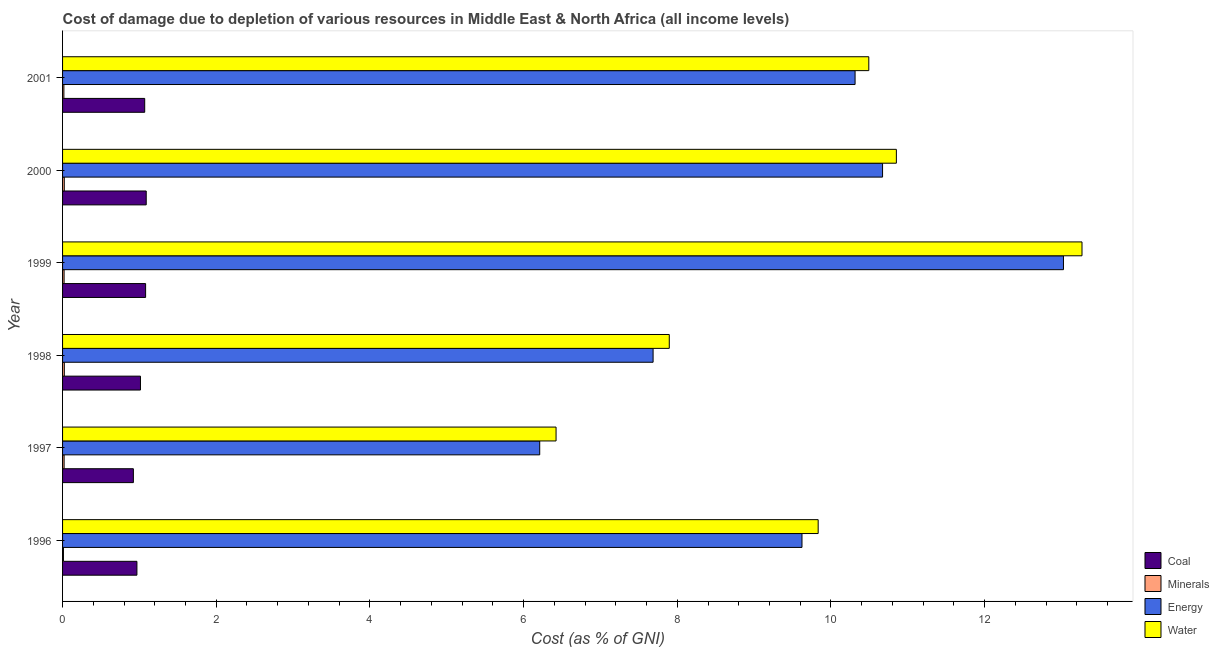Are the number of bars on each tick of the Y-axis equal?
Give a very brief answer. Yes. How many bars are there on the 5th tick from the top?
Provide a succinct answer. 4. How many bars are there on the 5th tick from the bottom?
Give a very brief answer. 4. What is the label of the 4th group of bars from the top?
Offer a terse response. 1998. In how many cases, is the number of bars for a given year not equal to the number of legend labels?
Give a very brief answer. 0. What is the cost of damage due to depletion of coal in 2000?
Provide a succinct answer. 1.09. Across all years, what is the maximum cost of damage due to depletion of coal?
Offer a very short reply. 1.09. Across all years, what is the minimum cost of damage due to depletion of minerals?
Keep it short and to the point. 0.01. In which year was the cost of damage due to depletion of water minimum?
Offer a very short reply. 1997. What is the total cost of damage due to depletion of coal in the graph?
Your answer should be very brief. 6.14. What is the difference between the cost of damage due to depletion of water in 1997 and that in 1998?
Your answer should be very brief. -1.47. What is the difference between the cost of damage due to depletion of coal in 1996 and the cost of damage due to depletion of water in 1998?
Keep it short and to the point. -6.93. What is the average cost of damage due to depletion of minerals per year?
Provide a short and direct response. 0.02. In the year 1999, what is the difference between the cost of damage due to depletion of coal and cost of damage due to depletion of energy?
Provide a short and direct response. -11.95. What is the ratio of the cost of damage due to depletion of minerals in 1996 to that in 1997?
Offer a terse response. 0.57. Is the difference between the cost of damage due to depletion of energy in 2000 and 2001 greater than the difference between the cost of damage due to depletion of minerals in 2000 and 2001?
Offer a very short reply. Yes. What is the difference between the highest and the second highest cost of damage due to depletion of water?
Your answer should be very brief. 2.42. What is the difference between the highest and the lowest cost of damage due to depletion of water?
Provide a succinct answer. 6.84. Is the sum of the cost of damage due to depletion of coal in 2000 and 2001 greater than the maximum cost of damage due to depletion of water across all years?
Keep it short and to the point. No. Is it the case that in every year, the sum of the cost of damage due to depletion of water and cost of damage due to depletion of energy is greater than the sum of cost of damage due to depletion of minerals and cost of damage due to depletion of coal?
Your answer should be compact. Yes. What does the 1st bar from the top in 1998 represents?
Ensure brevity in your answer.  Water. What does the 2nd bar from the bottom in 1998 represents?
Make the answer very short. Minerals. Is it the case that in every year, the sum of the cost of damage due to depletion of coal and cost of damage due to depletion of minerals is greater than the cost of damage due to depletion of energy?
Offer a terse response. No. How many years are there in the graph?
Your answer should be compact. 6. What is the difference between two consecutive major ticks on the X-axis?
Offer a very short reply. 2. Does the graph contain grids?
Your answer should be very brief. No. Where does the legend appear in the graph?
Provide a succinct answer. Bottom right. How many legend labels are there?
Offer a terse response. 4. How are the legend labels stacked?
Give a very brief answer. Vertical. What is the title of the graph?
Your answer should be very brief. Cost of damage due to depletion of various resources in Middle East & North Africa (all income levels) . Does "SF6 gas" appear as one of the legend labels in the graph?
Offer a very short reply. No. What is the label or title of the X-axis?
Keep it short and to the point. Cost (as % of GNI). What is the label or title of the Y-axis?
Provide a short and direct response. Year. What is the Cost (as % of GNI) in Coal in 1996?
Your response must be concise. 0.97. What is the Cost (as % of GNI) of Minerals in 1996?
Keep it short and to the point. 0.01. What is the Cost (as % of GNI) in Energy in 1996?
Provide a short and direct response. 9.62. What is the Cost (as % of GNI) in Water in 1996?
Provide a short and direct response. 9.83. What is the Cost (as % of GNI) of Coal in 1997?
Your answer should be compact. 0.92. What is the Cost (as % of GNI) of Minerals in 1997?
Offer a terse response. 0.02. What is the Cost (as % of GNI) in Energy in 1997?
Make the answer very short. 6.21. What is the Cost (as % of GNI) in Water in 1997?
Offer a terse response. 6.42. What is the Cost (as % of GNI) of Coal in 1998?
Give a very brief answer. 1.01. What is the Cost (as % of GNI) in Minerals in 1998?
Your answer should be compact. 0.02. What is the Cost (as % of GNI) of Energy in 1998?
Offer a terse response. 7.69. What is the Cost (as % of GNI) in Water in 1998?
Make the answer very short. 7.9. What is the Cost (as % of GNI) in Coal in 1999?
Your response must be concise. 1.08. What is the Cost (as % of GNI) of Minerals in 1999?
Give a very brief answer. 0.02. What is the Cost (as % of GNI) of Energy in 1999?
Offer a terse response. 13.03. What is the Cost (as % of GNI) in Water in 1999?
Provide a succinct answer. 13.27. What is the Cost (as % of GNI) of Coal in 2000?
Your answer should be very brief. 1.09. What is the Cost (as % of GNI) of Minerals in 2000?
Your answer should be compact. 0.02. What is the Cost (as % of GNI) of Energy in 2000?
Provide a succinct answer. 10.67. What is the Cost (as % of GNI) in Water in 2000?
Provide a short and direct response. 10.85. What is the Cost (as % of GNI) in Coal in 2001?
Your response must be concise. 1.07. What is the Cost (as % of GNI) in Minerals in 2001?
Provide a succinct answer. 0.02. What is the Cost (as % of GNI) of Energy in 2001?
Your response must be concise. 10.31. What is the Cost (as % of GNI) in Water in 2001?
Your answer should be compact. 10.49. Across all years, what is the maximum Cost (as % of GNI) of Coal?
Your answer should be compact. 1.09. Across all years, what is the maximum Cost (as % of GNI) in Minerals?
Ensure brevity in your answer.  0.02. Across all years, what is the maximum Cost (as % of GNI) of Energy?
Your response must be concise. 13.03. Across all years, what is the maximum Cost (as % of GNI) of Water?
Offer a terse response. 13.27. Across all years, what is the minimum Cost (as % of GNI) of Coal?
Make the answer very short. 0.92. Across all years, what is the minimum Cost (as % of GNI) in Minerals?
Offer a very short reply. 0.01. Across all years, what is the minimum Cost (as % of GNI) in Energy?
Your response must be concise. 6.21. Across all years, what is the minimum Cost (as % of GNI) of Water?
Offer a terse response. 6.42. What is the total Cost (as % of GNI) in Coal in the graph?
Provide a succinct answer. 6.14. What is the total Cost (as % of GNI) in Minerals in the graph?
Provide a short and direct response. 0.11. What is the total Cost (as % of GNI) in Energy in the graph?
Offer a very short reply. 57.53. What is the total Cost (as % of GNI) of Water in the graph?
Keep it short and to the point. 58.76. What is the difference between the Cost (as % of GNI) of Coal in 1996 and that in 1997?
Keep it short and to the point. 0.05. What is the difference between the Cost (as % of GNI) of Minerals in 1996 and that in 1997?
Your response must be concise. -0.01. What is the difference between the Cost (as % of GNI) in Energy in 1996 and that in 1997?
Keep it short and to the point. 3.41. What is the difference between the Cost (as % of GNI) in Water in 1996 and that in 1997?
Your answer should be very brief. 3.41. What is the difference between the Cost (as % of GNI) of Coal in 1996 and that in 1998?
Your response must be concise. -0.05. What is the difference between the Cost (as % of GNI) of Minerals in 1996 and that in 1998?
Offer a very short reply. -0.01. What is the difference between the Cost (as % of GNI) of Energy in 1996 and that in 1998?
Offer a very short reply. 1.94. What is the difference between the Cost (as % of GNI) in Water in 1996 and that in 1998?
Give a very brief answer. 1.94. What is the difference between the Cost (as % of GNI) of Coal in 1996 and that in 1999?
Provide a succinct answer. -0.11. What is the difference between the Cost (as % of GNI) of Minerals in 1996 and that in 1999?
Ensure brevity in your answer.  -0.01. What is the difference between the Cost (as % of GNI) of Energy in 1996 and that in 1999?
Make the answer very short. -3.4. What is the difference between the Cost (as % of GNI) in Water in 1996 and that in 1999?
Your response must be concise. -3.43. What is the difference between the Cost (as % of GNI) of Coal in 1996 and that in 2000?
Ensure brevity in your answer.  -0.12. What is the difference between the Cost (as % of GNI) in Minerals in 1996 and that in 2000?
Your answer should be compact. -0.01. What is the difference between the Cost (as % of GNI) in Energy in 1996 and that in 2000?
Ensure brevity in your answer.  -1.05. What is the difference between the Cost (as % of GNI) of Water in 1996 and that in 2000?
Your response must be concise. -1.02. What is the difference between the Cost (as % of GNI) in Coal in 1996 and that in 2001?
Your answer should be compact. -0.1. What is the difference between the Cost (as % of GNI) of Minerals in 1996 and that in 2001?
Provide a short and direct response. -0.01. What is the difference between the Cost (as % of GNI) in Energy in 1996 and that in 2001?
Give a very brief answer. -0.69. What is the difference between the Cost (as % of GNI) of Water in 1996 and that in 2001?
Ensure brevity in your answer.  -0.66. What is the difference between the Cost (as % of GNI) in Coal in 1997 and that in 1998?
Your answer should be compact. -0.09. What is the difference between the Cost (as % of GNI) in Minerals in 1997 and that in 1998?
Offer a terse response. -0. What is the difference between the Cost (as % of GNI) of Energy in 1997 and that in 1998?
Provide a short and direct response. -1.48. What is the difference between the Cost (as % of GNI) of Water in 1997 and that in 1998?
Your answer should be compact. -1.47. What is the difference between the Cost (as % of GNI) in Coal in 1997 and that in 1999?
Your answer should be compact. -0.16. What is the difference between the Cost (as % of GNI) in Energy in 1997 and that in 1999?
Your response must be concise. -6.82. What is the difference between the Cost (as % of GNI) in Water in 1997 and that in 1999?
Your answer should be compact. -6.84. What is the difference between the Cost (as % of GNI) in Coal in 1997 and that in 2000?
Provide a succinct answer. -0.17. What is the difference between the Cost (as % of GNI) in Minerals in 1997 and that in 2000?
Your answer should be very brief. -0. What is the difference between the Cost (as % of GNI) in Energy in 1997 and that in 2000?
Your response must be concise. -4.46. What is the difference between the Cost (as % of GNI) of Water in 1997 and that in 2000?
Your response must be concise. -4.43. What is the difference between the Cost (as % of GNI) of Coal in 1997 and that in 2001?
Your response must be concise. -0.15. What is the difference between the Cost (as % of GNI) in Minerals in 1997 and that in 2001?
Provide a short and direct response. 0. What is the difference between the Cost (as % of GNI) of Energy in 1997 and that in 2001?
Make the answer very short. -4.1. What is the difference between the Cost (as % of GNI) of Water in 1997 and that in 2001?
Your answer should be compact. -4.07. What is the difference between the Cost (as % of GNI) in Coal in 1998 and that in 1999?
Your answer should be very brief. -0.07. What is the difference between the Cost (as % of GNI) in Minerals in 1998 and that in 1999?
Make the answer very short. 0. What is the difference between the Cost (as % of GNI) of Energy in 1998 and that in 1999?
Keep it short and to the point. -5.34. What is the difference between the Cost (as % of GNI) of Water in 1998 and that in 1999?
Ensure brevity in your answer.  -5.37. What is the difference between the Cost (as % of GNI) in Coal in 1998 and that in 2000?
Provide a succinct answer. -0.07. What is the difference between the Cost (as % of GNI) of Minerals in 1998 and that in 2000?
Give a very brief answer. 0. What is the difference between the Cost (as % of GNI) of Energy in 1998 and that in 2000?
Ensure brevity in your answer.  -2.99. What is the difference between the Cost (as % of GNI) of Water in 1998 and that in 2000?
Keep it short and to the point. -2.96. What is the difference between the Cost (as % of GNI) of Coal in 1998 and that in 2001?
Your answer should be very brief. -0.06. What is the difference between the Cost (as % of GNI) of Minerals in 1998 and that in 2001?
Give a very brief answer. 0.01. What is the difference between the Cost (as % of GNI) in Energy in 1998 and that in 2001?
Make the answer very short. -2.63. What is the difference between the Cost (as % of GNI) in Water in 1998 and that in 2001?
Make the answer very short. -2.6. What is the difference between the Cost (as % of GNI) of Coal in 1999 and that in 2000?
Make the answer very short. -0.01. What is the difference between the Cost (as % of GNI) in Minerals in 1999 and that in 2000?
Make the answer very short. -0. What is the difference between the Cost (as % of GNI) of Energy in 1999 and that in 2000?
Your answer should be very brief. 2.35. What is the difference between the Cost (as % of GNI) of Water in 1999 and that in 2000?
Ensure brevity in your answer.  2.42. What is the difference between the Cost (as % of GNI) of Coal in 1999 and that in 2001?
Offer a very short reply. 0.01. What is the difference between the Cost (as % of GNI) in Minerals in 1999 and that in 2001?
Your response must be concise. 0. What is the difference between the Cost (as % of GNI) in Energy in 1999 and that in 2001?
Your answer should be very brief. 2.71. What is the difference between the Cost (as % of GNI) in Water in 1999 and that in 2001?
Your answer should be very brief. 2.77. What is the difference between the Cost (as % of GNI) in Coal in 2000 and that in 2001?
Make the answer very short. 0.02. What is the difference between the Cost (as % of GNI) in Minerals in 2000 and that in 2001?
Your answer should be compact. 0.01. What is the difference between the Cost (as % of GNI) in Energy in 2000 and that in 2001?
Make the answer very short. 0.36. What is the difference between the Cost (as % of GNI) of Water in 2000 and that in 2001?
Offer a terse response. 0.36. What is the difference between the Cost (as % of GNI) in Coal in 1996 and the Cost (as % of GNI) in Minerals in 1997?
Keep it short and to the point. 0.95. What is the difference between the Cost (as % of GNI) in Coal in 1996 and the Cost (as % of GNI) in Energy in 1997?
Ensure brevity in your answer.  -5.24. What is the difference between the Cost (as % of GNI) in Coal in 1996 and the Cost (as % of GNI) in Water in 1997?
Offer a very short reply. -5.45. What is the difference between the Cost (as % of GNI) in Minerals in 1996 and the Cost (as % of GNI) in Energy in 1997?
Your answer should be very brief. -6.2. What is the difference between the Cost (as % of GNI) of Minerals in 1996 and the Cost (as % of GNI) of Water in 1997?
Keep it short and to the point. -6.41. What is the difference between the Cost (as % of GNI) of Energy in 1996 and the Cost (as % of GNI) of Water in 1997?
Your answer should be compact. 3.2. What is the difference between the Cost (as % of GNI) in Coal in 1996 and the Cost (as % of GNI) in Minerals in 1998?
Make the answer very short. 0.94. What is the difference between the Cost (as % of GNI) in Coal in 1996 and the Cost (as % of GNI) in Energy in 1998?
Make the answer very short. -6.72. What is the difference between the Cost (as % of GNI) of Coal in 1996 and the Cost (as % of GNI) of Water in 1998?
Your response must be concise. -6.93. What is the difference between the Cost (as % of GNI) in Minerals in 1996 and the Cost (as % of GNI) in Energy in 1998?
Your response must be concise. -7.67. What is the difference between the Cost (as % of GNI) of Minerals in 1996 and the Cost (as % of GNI) of Water in 1998?
Give a very brief answer. -7.88. What is the difference between the Cost (as % of GNI) in Energy in 1996 and the Cost (as % of GNI) in Water in 1998?
Make the answer very short. 1.73. What is the difference between the Cost (as % of GNI) of Coal in 1996 and the Cost (as % of GNI) of Minerals in 1999?
Make the answer very short. 0.95. What is the difference between the Cost (as % of GNI) in Coal in 1996 and the Cost (as % of GNI) in Energy in 1999?
Offer a very short reply. -12.06. What is the difference between the Cost (as % of GNI) in Coal in 1996 and the Cost (as % of GNI) in Water in 1999?
Provide a short and direct response. -12.3. What is the difference between the Cost (as % of GNI) of Minerals in 1996 and the Cost (as % of GNI) of Energy in 1999?
Your answer should be very brief. -13.01. What is the difference between the Cost (as % of GNI) in Minerals in 1996 and the Cost (as % of GNI) in Water in 1999?
Make the answer very short. -13.26. What is the difference between the Cost (as % of GNI) in Energy in 1996 and the Cost (as % of GNI) in Water in 1999?
Your answer should be very brief. -3.64. What is the difference between the Cost (as % of GNI) of Coal in 1996 and the Cost (as % of GNI) of Minerals in 2000?
Your response must be concise. 0.95. What is the difference between the Cost (as % of GNI) in Coal in 1996 and the Cost (as % of GNI) in Energy in 2000?
Give a very brief answer. -9.7. What is the difference between the Cost (as % of GNI) of Coal in 1996 and the Cost (as % of GNI) of Water in 2000?
Your response must be concise. -9.88. What is the difference between the Cost (as % of GNI) of Minerals in 1996 and the Cost (as % of GNI) of Energy in 2000?
Offer a terse response. -10.66. What is the difference between the Cost (as % of GNI) in Minerals in 1996 and the Cost (as % of GNI) in Water in 2000?
Offer a terse response. -10.84. What is the difference between the Cost (as % of GNI) of Energy in 1996 and the Cost (as % of GNI) of Water in 2000?
Your answer should be very brief. -1.23. What is the difference between the Cost (as % of GNI) in Coal in 1996 and the Cost (as % of GNI) in Minerals in 2001?
Provide a succinct answer. 0.95. What is the difference between the Cost (as % of GNI) of Coal in 1996 and the Cost (as % of GNI) of Energy in 2001?
Keep it short and to the point. -9.35. What is the difference between the Cost (as % of GNI) of Coal in 1996 and the Cost (as % of GNI) of Water in 2001?
Provide a succinct answer. -9.52. What is the difference between the Cost (as % of GNI) in Minerals in 1996 and the Cost (as % of GNI) in Energy in 2001?
Offer a terse response. -10.3. What is the difference between the Cost (as % of GNI) in Minerals in 1996 and the Cost (as % of GNI) in Water in 2001?
Offer a very short reply. -10.48. What is the difference between the Cost (as % of GNI) in Energy in 1996 and the Cost (as % of GNI) in Water in 2001?
Give a very brief answer. -0.87. What is the difference between the Cost (as % of GNI) of Coal in 1997 and the Cost (as % of GNI) of Minerals in 1998?
Ensure brevity in your answer.  0.9. What is the difference between the Cost (as % of GNI) in Coal in 1997 and the Cost (as % of GNI) in Energy in 1998?
Your answer should be compact. -6.76. What is the difference between the Cost (as % of GNI) of Coal in 1997 and the Cost (as % of GNI) of Water in 1998?
Provide a succinct answer. -6.97. What is the difference between the Cost (as % of GNI) in Minerals in 1997 and the Cost (as % of GNI) in Energy in 1998?
Your answer should be very brief. -7.67. What is the difference between the Cost (as % of GNI) in Minerals in 1997 and the Cost (as % of GNI) in Water in 1998?
Provide a succinct answer. -7.88. What is the difference between the Cost (as % of GNI) of Energy in 1997 and the Cost (as % of GNI) of Water in 1998?
Keep it short and to the point. -1.69. What is the difference between the Cost (as % of GNI) in Coal in 1997 and the Cost (as % of GNI) in Minerals in 1999?
Give a very brief answer. 0.9. What is the difference between the Cost (as % of GNI) in Coal in 1997 and the Cost (as % of GNI) in Energy in 1999?
Ensure brevity in your answer.  -12.1. What is the difference between the Cost (as % of GNI) in Coal in 1997 and the Cost (as % of GNI) in Water in 1999?
Your answer should be very brief. -12.35. What is the difference between the Cost (as % of GNI) in Minerals in 1997 and the Cost (as % of GNI) in Energy in 1999?
Offer a terse response. -13.01. What is the difference between the Cost (as % of GNI) in Minerals in 1997 and the Cost (as % of GNI) in Water in 1999?
Offer a very short reply. -13.25. What is the difference between the Cost (as % of GNI) in Energy in 1997 and the Cost (as % of GNI) in Water in 1999?
Offer a very short reply. -7.06. What is the difference between the Cost (as % of GNI) in Coal in 1997 and the Cost (as % of GNI) in Minerals in 2000?
Your answer should be very brief. 0.9. What is the difference between the Cost (as % of GNI) of Coal in 1997 and the Cost (as % of GNI) of Energy in 2000?
Give a very brief answer. -9.75. What is the difference between the Cost (as % of GNI) in Coal in 1997 and the Cost (as % of GNI) in Water in 2000?
Your answer should be compact. -9.93. What is the difference between the Cost (as % of GNI) in Minerals in 1997 and the Cost (as % of GNI) in Energy in 2000?
Your answer should be very brief. -10.65. What is the difference between the Cost (as % of GNI) of Minerals in 1997 and the Cost (as % of GNI) of Water in 2000?
Your answer should be very brief. -10.83. What is the difference between the Cost (as % of GNI) in Energy in 1997 and the Cost (as % of GNI) in Water in 2000?
Ensure brevity in your answer.  -4.64. What is the difference between the Cost (as % of GNI) of Coal in 1997 and the Cost (as % of GNI) of Minerals in 2001?
Provide a short and direct response. 0.9. What is the difference between the Cost (as % of GNI) of Coal in 1997 and the Cost (as % of GNI) of Energy in 2001?
Ensure brevity in your answer.  -9.39. What is the difference between the Cost (as % of GNI) of Coal in 1997 and the Cost (as % of GNI) of Water in 2001?
Provide a succinct answer. -9.57. What is the difference between the Cost (as % of GNI) in Minerals in 1997 and the Cost (as % of GNI) in Energy in 2001?
Ensure brevity in your answer.  -10.29. What is the difference between the Cost (as % of GNI) in Minerals in 1997 and the Cost (as % of GNI) in Water in 2001?
Your answer should be compact. -10.47. What is the difference between the Cost (as % of GNI) of Energy in 1997 and the Cost (as % of GNI) of Water in 2001?
Give a very brief answer. -4.28. What is the difference between the Cost (as % of GNI) in Coal in 1998 and the Cost (as % of GNI) in Energy in 1999?
Ensure brevity in your answer.  -12.01. What is the difference between the Cost (as % of GNI) in Coal in 1998 and the Cost (as % of GNI) in Water in 1999?
Keep it short and to the point. -12.25. What is the difference between the Cost (as % of GNI) of Minerals in 1998 and the Cost (as % of GNI) of Energy in 1999?
Ensure brevity in your answer.  -13. What is the difference between the Cost (as % of GNI) in Minerals in 1998 and the Cost (as % of GNI) in Water in 1999?
Your response must be concise. -13.24. What is the difference between the Cost (as % of GNI) of Energy in 1998 and the Cost (as % of GNI) of Water in 1999?
Keep it short and to the point. -5.58. What is the difference between the Cost (as % of GNI) in Coal in 1998 and the Cost (as % of GNI) in Energy in 2000?
Provide a short and direct response. -9.66. What is the difference between the Cost (as % of GNI) in Coal in 1998 and the Cost (as % of GNI) in Water in 2000?
Give a very brief answer. -9.84. What is the difference between the Cost (as % of GNI) in Minerals in 1998 and the Cost (as % of GNI) in Energy in 2000?
Your answer should be very brief. -10.65. What is the difference between the Cost (as % of GNI) of Minerals in 1998 and the Cost (as % of GNI) of Water in 2000?
Keep it short and to the point. -10.83. What is the difference between the Cost (as % of GNI) in Energy in 1998 and the Cost (as % of GNI) in Water in 2000?
Give a very brief answer. -3.17. What is the difference between the Cost (as % of GNI) in Coal in 1998 and the Cost (as % of GNI) in Minerals in 2001?
Offer a terse response. 1. What is the difference between the Cost (as % of GNI) of Coal in 1998 and the Cost (as % of GNI) of Energy in 2001?
Provide a succinct answer. -9.3. What is the difference between the Cost (as % of GNI) of Coal in 1998 and the Cost (as % of GNI) of Water in 2001?
Your answer should be compact. -9.48. What is the difference between the Cost (as % of GNI) in Minerals in 1998 and the Cost (as % of GNI) in Energy in 2001?
Give a very brief answer. -10.29. What is the difference between the Cost (as % of GNI) of Minerals in 1998 and the Cost (as % of GNI) of Water in 2001?
Keep it short and to the point. -10.47. What is the difference between the Cost (as % of GNI) in Energy in 1998 and the Cost (as % of GNI) in Water in 2001?
Keep it short and to the point. -2.81. What is the difference between the Cost (as % of GNI) of Coal in 1999 and the Cost (as % of GNI) of Minerals in 2000?
Offer a very short reply. 1.06. What is the difference between the Cost (as % of GNI) in Coal in 1999 and the Cost (as % of GNI) in Energy in 2000?
Provide a succinct answer. -9.59. What is the difference between the Cost (as % of GNI) in Coal in 1999 and the Cost (as % of GNI) in Water in 2000?
Ensure brevity in your answer.  -9.77. What is the difference between the Cost (as % of GNI) of Minerals in 1999 and the Cost (as % of GNI) of Energy in 2000?
Make the answer very short. -10.65. What is the difference between the Cost (as % of GNI) in Minerals in 1999 and the Cost (as % of GNI) in Water in 2000?
Your answer should be very brief. -10.83. What is the difference between the Cost (as % of GNI) of Energy in 1999 and the Cost (as % of GNI) of Water in 2000?
Offer a terse response. 2.17. What is the difference between the Cost (as % of GNI) of Coal in 1999 and the Cost (as % of GNI) of Minerals in 2001?
Offer a terse response. 1.06. What is the difference between the Cost (as % of GNI) in Coal in 1999 and the Cost (as % of GNI) in Energy in 2001?
Keep it short and to the point. -9.23. What is the difference between the Cost (as % of GNI) in Coal in 1999 and the Cost (as % of GNI) in Water in 2001?
Offer a terse response. -9.41. What is the difference between the Cost (as % of GNI) of Minerals in 1999 and the Cost (as % of GNI) of Energy in 2001?
Offer a terse response. -10.29. What is the difference between the Cost (as % of GNI) of Minerals in 1999 and the Cost (as % of GNI) of Water in 2001?
Give a very brief answer. -10.47. What is the difference between the Cost (as % of GNI) of Energy in 1999 and the Cost (as % of GNI) of Water in 2001?
Your response must be concise. 2.53. What is the difference between the Cost (as % of GNI) in Coal in 2000 and the Cost (as % of GNI) in Minerals in 2001?
Your response must be concise. 1.07. What is the difference between the Cost (as % of GNI) in Coal in 2000 and the Cost (as % of GNI) in Energy in 2001?
Provide a succinct answer. -9.22. What is the difference between the Cost (as % of GNI) of Coal in 2000 and the Cost (as % of GNI) of Water in 2001?
Your answer should be compact. -9.4. What is the difference between the Cost (as % of GNI) in Minerals in 2000 and the Cost (as % of GNI) in Energy in 2001?
Make the answer very short. -10.29. What is the difference between the Cost (as % of GNI) of Minerals in 2000 and the Cost (as % of GNI) of Water in 2001?
Your answer should be compact. -10.47. What is the difference between the Cost (as % of GNI) of Energy in 2000 and the Cost (as % of GNI) of Water in 2001?
Your response must be concise. 0.18. What is the average Cost (as % of GNI) of Coal per year?
Your response must be concise. 1.02. What is the average Cost (as % of GNI) in Minerals per year?
Your answer should be compact. 0.02. What is the average Cost (as % of GNI) of Energy per year?
Provide a succinct answer. 9.59. What is the average Cost (as % of GNI) of Water per year?
Make the answer very short. 9.79. In the year 1996, what is the difference between the Cost (as % of GNI) of Coal and Cost (as % of GNI) of Minerals?
Offer a very short reply. 0.96. In the year 1996, what is the difference between the Cost (as % of GNI) of Coal and Cost (as % of GNI) of Energy?
Offer a very short reply. -8.66. In the year 1996, what is the difference between the Cost (as % of GNI) of Coal and Cost (as % of GNI) of Water?
Your response must be concise. -8.87. In the year 1996, what is the difference between the Cost (as % of GNI) in Minerals and Cost (as % of GNI) in Energy?
Provide a short and direct response. -9.61. In the year 1996, what is the difference between the Cost (as % of GNI) in Minerals and Cost (as % of GNI) in Water?
Provide a succinct answer. -9.82. In the year 1996, what is the difference between the Cost (as % of GNI) of Energy and Cost (as % of GNI) of Water?
Your answer should be compact. -0.21. In the year 1997, what is the difference between the Cost (as % of GNI) of Coal and Cost (as % of GNI) of Minerals?
Keep it short and to the point. 0.9. In the year 1997, what is the difference between the Cost (as % of GNI) in Coal and Cost (as % of GNI) in Energy?
Offer a very short reply. -5.29. In the year 1997, what is the difference between the Cost (as % of GNI) of Coal and Cost (as % of GNI) of Water?
Give a very brief answer. -5.5. In the year 1997, what is the difference between the Cost (as % of GNI) of Minerals and Cost (as % of GNI) of Energy?
Your answer should be very brief. -6.19. In the year 1997, what is the difference between the Cost (as % of GNI) in Minerals and Cost (as % of GNI) in Water?
Your answer should be compact. -6.4. In the year 1997, what is the difference between the Cost (as % of GNI) of Energy and Cost (as % of GNI) of Water?
Keep it short and to the point. -0.21. In the year 1998, what is the difference between the Cost (as % of GNI) of Coal and Cost (as % of GNI) of Minerals?
Offer a terse response. 0.99. In the year 1998, what is the difference between the Cost (as % of GNI) in Coal and Cost (as % of GNI) in Energy?
Give a very brief answer. -6.67. In the year 1998, what is the difference between the Cost (as % of GNI) in Coal and Cost (as % of GNI) in Water?
Provide a short and direct response. -6.88. In the year 1998, what is the difference between the Cost (as % of GNI) of Minerals and Cost (as % of GNI) of Energy?
Offer a terse response. -7.66. In the year 1998, what is the difference between the Cost (as % of GNI) in Minerals and Cost (as % of GNI) in Water?
Make the answer very short. -7.87. In the year 1998, what is the difference between the Cost (as % of GNI) of Energy and Cost (as % of GNI) of Water?
Make the answer very short. -0.21. In the year 1999, what is the difference between the Cost (as % of GNI) of Coal and Cost (as % of GNI) of Minerals?
Give a very brief answer. 1.06. In the year 1999, what is the difference between the Cost (as % of GNI) of Coal and Cost (as % of GNI) of Energy?
Your answer should be very brief. -11.94. In the year 1999, what is the difference between the Cost (as % of GNI) of Coal and Cost (as % of GNI) of Water?
Offer a terse response. -12.19. In the year 1999, what is the difference between the Cost (as % of GNI) of Minerals and Cost (as % of GNI) of Energy?
Offer a very short reply. -13.01. In the year 1999, what is the difference between the Cost (as % of GNI) of Minerals and Cost (as % of GNI) of Water?
Your answer should be very brief. -13.25. In the year 1999, what is the difference between the Cost (as % of GNI) of Energy and Cost (as % of GNI) of Water?
Your answer should be very brief. -0.24. In the year 2000, what is the difference between the Cost (as % of GNI) in Coal and Cost (as % of GNI) in Minerals?
Offer a terse response. 1.07. In the year 2000, what is the difference between the Cost (as % of GNI) in Coal and Cost (as % of GNI) in Energy?
Your response must be concise. -9.58. In the year 2000, what is the difference between the Cost (as % of GNI) of Coal and Cost (as % of GNI) of Water?
Offer a very short reply. -9.76. In the year 2000, what is the difference between the Cost (as % of GNI) of Minerals and Cost (as % of GNI) of Energy?
Give a very brief answer. -10.65. In the year 2000, what is the difference between the Cost (as % of GNI) of Minerals and Cost (as % of GNI) of Water?
Keep it short and to the point. -10.83. In the year 2000, what is the difference between the Cost (as % of GNI) in Energy and Cost (as % of GNI) in Water?
Provide a succinct answer. -0.18. In the year 2001, what is the difference between the Cost (as % of GNI) of Coal and Cost (as % of GNI) of Minerals?
Provide a succinct answer. 1.05. In the year 2001, what is the difference between the Cost (as % of GNI) of Coal and Cost (as % of GNI) of Energy?
Provide a short and direct response. -9.24. In the year 2001, what is the difference between the Cost (as % of GNI) in Coal and Cost (as % of GNI) in Water?
Provide a succinct answer. -9.42. In the year 2001, what is the difference between the Cost (as % of GNI) of Minerals and Cost (as % of GNI) of Energy?
Provide a short and direct response. -10.3. In the year 2001, what is the difference between the Cost (as % of GNI) in Minerals and Cost (as % of GNI) in Water?
Your answer should be compact. -10.47. In the year 2001, what is the difference between the Cost (as % of GNI) in Energy and Cost (as % of GNI) in Water?
Give a very brief answer. -0.18. What is the ratio of the Cost (as % of GNI) of Coal in 1996 to that in 1997?
Ensure brevity in your answer.  1.05. What is the ratio of the Cost (as % of GNI) in Minerals in 1996 to that in 1997?
Make the answer very short. 0.57. What is the ratio of the Cost (as % of GNI) of Energy in 1996 to that in 1997?
Provide a short and direct response. 1.55. What is the ratio of the Cost (as % of GNI) of Water in 1996 to that in 1997?
Provide a short and direct response. 1.53. What is the ratio of the Cost (as % of GNI) of Coal in 1996 to that in 1998?
Your answer should be compact. 0.95. What is the ratio of the Cost (as % of GNI) of Minerals in 1996 to that in 1998?
Keep it short and to the point. 0.5. What is the ratio of the Cost (as % of GNI) of Energy in 1996 to that in 1998?
Your answer should be compact. 1.25. What is the ratio of the Cost (as % of GNI) of Water in 1996 to that in 1998?
Provide a short and direct response. 1.25. What is the ratio of the Cost (as % of GNI) in Coal in 1996 to that in 1999?
Make the answer very short. 0.9. What is the ratio of the Cost (as % of GNI) in Minerals in 1996 to that in 1999?
Offer a very short reply. 0.58. What is the ratio of the Cost (as % of GNI) in Energy in 1996 to that in 1999?
Make the answer very short. 0.74. What is the ratio of the Cost (as % of GNI) of Water in 1996 to that in 1999?
Offer a very short reply. 0.74. What is the ratio of the Cost (as % of GNI) in Coal in 1996 to that in 2000?
Offer a terse response. 0.89. What is the ratio of the Cost (as % of GNI) in Minerals in 1996 to that in 2000?
Provide a succinct answer. 0.51. What is the ratio of the Cost (as % of GNI) in Energy in 1996 to that in 2000?
Give a very brief answer. 0.9. What is the ratio of the Cost (as % of GNI) of Water in 1996 to that in 2000?
Your response must be concise. 0.91. What is the ratio of the Cost (as % of GNI) in Coal in 1996 to that in 2001?
Give a very brief answer. 0.91. What is the ratio of the Cost (as % of GNI) in Minerals in 1996 to that in 2001?
Ensure brevity in your answer.  0.66. What is the ratio of the Cost (as % of GNI) of Energy in 1996 to that in 2001?
Give a very brief answer. 0.93. What is the ratio of the Cost (as % of GNI) in Water in 1996 to that in 2001?
Your answer should be very brief. 0.94. What is the ratio of the Cost (as % of GNI) of Coal in 1997 to that in 1998?
Ensure brevity in your answer.  0.91. What is the ratio of the Cost (as % of GNI) of Minerals in 1997 to that in 1998?
Give a very brief answer. 0.88. What is the ratio of the Cost (as % of GNI) in Energy in 1997 to that in 1998?
Give a very brief answer. 0.81. What is the ratio of the Cost (as % of GNI) of Water in 1997 to that in 1998?
Your response must be concise. 0.81. What is the ratio of the Cost (as % of GNI) of Coal in 1997 to that in 1999?
Ensure brevity in your answer.  0.85. What is the ratio of the Cost (as % of GNI) in Energy in 1997 to that in 1999?
Your answer should be very brief. 0.48. What is the ratio of the Cost (as % of GNI) of Water in 1997 to that in 1999?
Keep it short and to the point. 0.48. What is the ratio of the Cost (as % of GNI) in Coal in 1997 to that in 2000?
Make the answer very short. 0.85. What is the ratio of the Cost (as % of GNI) in Minerals in 1997 to that in 2000?
Give a very brief answer. 0.9. What is the ratio of the Cost (as % of GNI) of Energy in 1997 to that in 2000?
Your response must be concise. 0.58. What is the ratio of the Cost (as % of GNI) in Water in 1997 to that in 2000?
Provide a succinct answer. 0.59. What is the ratio of the Cost (as % of GNI) of Coal in 1997 to that in 2001?
Your response must be concise. 0.86. What is the ratio of the Cost (as % of GNI) in Minerals in 1997 to that in 2001?
Your answer should be very brief. 1.15. What is the ratio of the Cost (as % of GNI) of Energy in 1997 to that in 2001?
Ensure brevity in your answer.  0.6. What is the ratio of the Cost (as % of GNI) of Water in 1997 to that in 2001?
Provide a succinct answer. 0.61. What is the ratio of the Cost (as % of GNI) in Coal in 1998 to that in 1999?
Your response must be concise. 0.94. What is the ratio of the Cost (as % of GNI) in Minerals in 1998 to that in 1999?
Provide a succinct answer. 1.14. What is the ratio of the Cost (as % of GNI) of Energy in 1998 to that in 1999?
Provide a short and direct response. 0.59. What is the ratio of the Cost (as % of GNI) in Water in 1998 to that in 1999?
Make the answer very short. 0.6. What is the ratio of the Cost (as % of GNI) of Coal in 1998 to that in 2000?
Give a very brief answer. 0.93. What is the ratio of the Cost (as % of GNI) of Minerals in 1998 to that in 2000?
Give a very brief answer. 1.02. What is the ratio of the Cost (as % of GNI) in Energy in 1998 to that in 2000?
Provide a succinct answer. 0.72. What is the ratio of the Cost (as % of GNI) of Water in 1998 to that in 2000?
Make the answer very short. 0.73. What is the ratio of the Cost (as % of GNI) in Coal in 1998 to that in 2001?
Give a very brief answer. 0.95. What is the ratio of the Cost (as % of GNI) of Minerals in 1998 to that in 2001?
Ensure brevity in your answer.  1.31. What is the ratio of the Cost (as % of GNI) in Energy in 1998 to that in 2001?
Your answer should be compact. 0.75. What is the ratio of the Cost (as % of GNI) in Water in 1998 to that in 2001?
Your response must be concise. 0.75. What is the ratio of the Cost (as % of GNI) of Minerals in 1999 to that in 2000?
Offer a terse response. 0.89. What is the ratio of the Cost (as % of GNI) of Energy in 1999 to that in 2000?
Your answer should be very brief. 1.22. What is the ratio of the Cost (as % of GNI) of Water in 1999 to that in 2000?
Your response must be concise. 1.22. What is the ratio of the Cost (as % of GNI) of Minerals in 1999 to that in 2001?
Ensure brevity in your answer.  1.15. What is the ratio of the Cost (as % of GNI) in Energy in 1999 to that in 2001?
Ensure brevity in your answer.  1.26. What is the ratio of the Cost (as % of GNI) of Water in 1999 to that in 2001?
Give a very brief answer. 1.26. What is the ratio of the Cost (as % of GNI) of Coal in 2000 to that in 2001?
Your answer should be compact. 1.02. What is the ratio of the Cost (as % of GNI) in Minerals in 2000 to that in 2001?
Offer a terse response. 1.29. What is the ratio of the Cost (as % of GNI) in Energy in 2000 to that in 2001?
Keep it short and to the point. 1.03. What is the ratio of the Cost (as % of GNI) in Water in 2000 to that in 2001?
Ensure brevity in your answer.  1.03. What is the difference between the highest and the second highest Cost (as % of GNI) of Coal?
Ensure brevity in your answer.  0.01. What is the difference between the highest and the second highest Cost (as % of GNI) in Energy?
Provide a short and direct response. 2.35. What is the difference between the highest and the second highest Cost (as % of GNI) in Water?
Provide a succinct answer. 2.42. What is the difference between the highest and the lowest Cost (as % of GNI) in Coal?
Your answer should be very brief. 0.17. What is the difference between the highest and the lowest Cost (as % of GNI) of Minerals?
Offer a very short reply. 0.01. What is the difference between the highest and the lowest Cost (as % of GNI) of Energy?
Provide a succinct answer. 6.82. What is the difference between the highest and the lowest Cost (as % of GNI) in Water?
Make the answer very short. 6.84. 